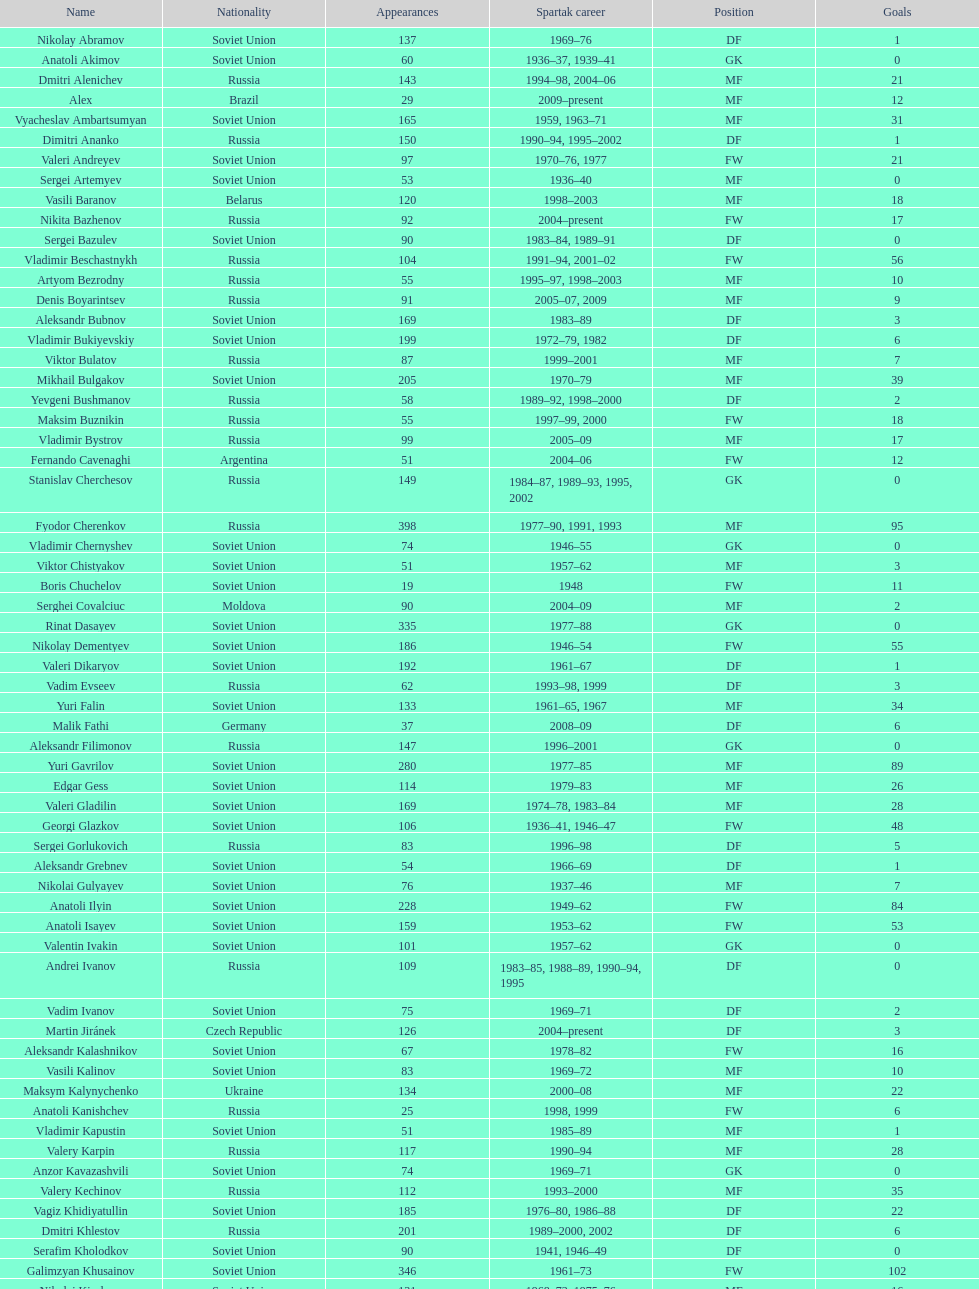Who had the highest number of appearances? Fyodor Cherenkov. 